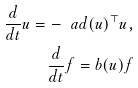Convert formula to latex. <formula><loc_0><loc_0><loc_500><loc_500>\frac { d } { d t } u = - \ a d ( u ) ^ { \top } u , \\ \frac { d } { d t } f = b ( u ) f</formula> 